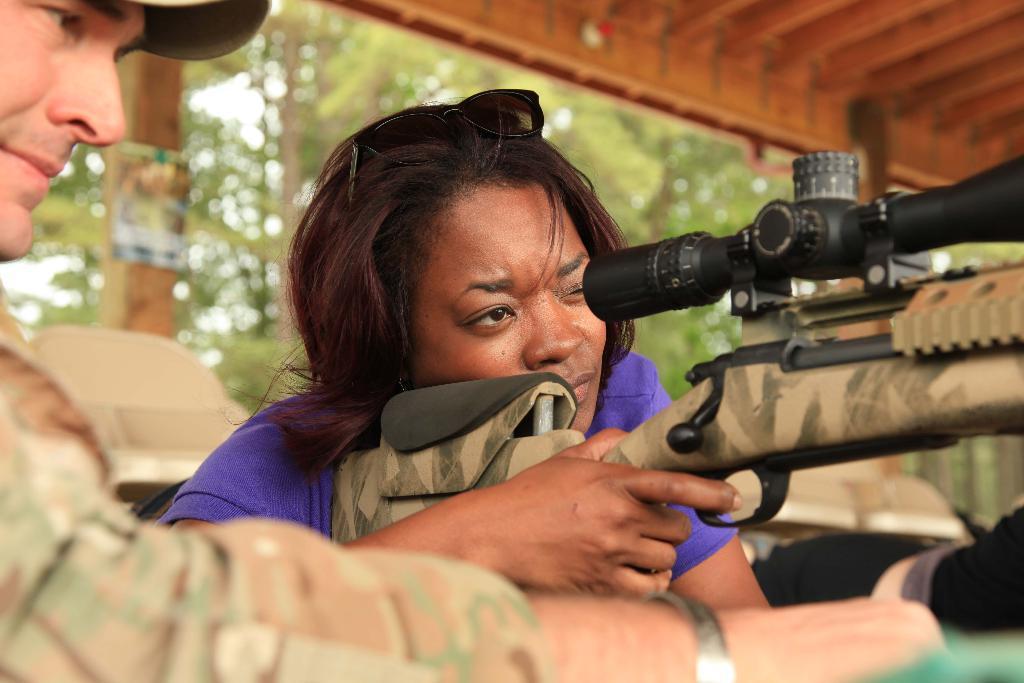Describe this image in one or two sentences. In this image, we can see a woman is holding a gun. Left side of the image, we can see a person. Background we can see few trees, pillar, some poster here. Top of the image, there is a roof. 